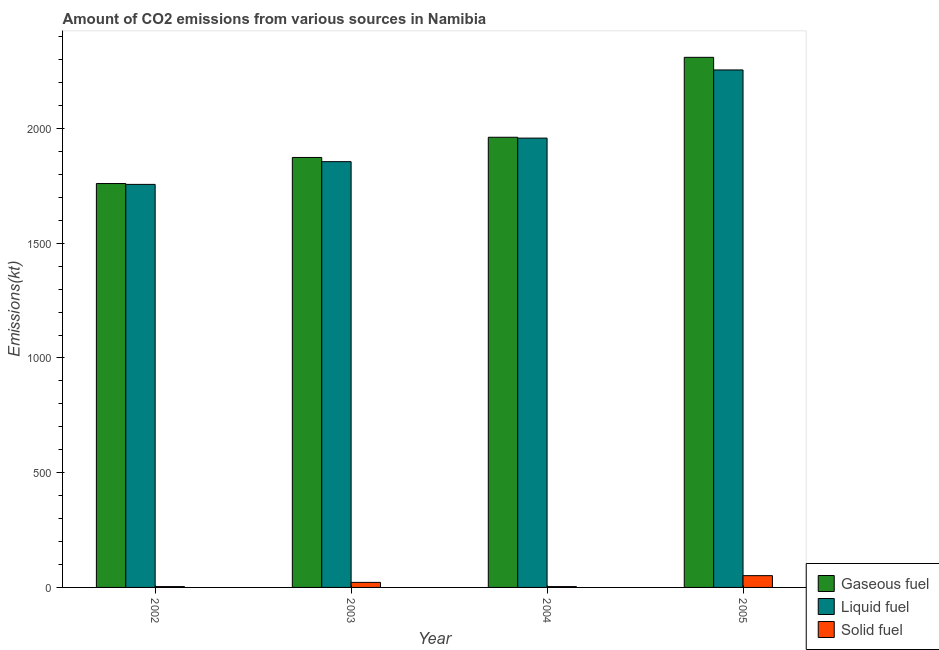How many different coloured bars are there?
Provide a short and direct response. 3. How many groups of bars are there?
Provide a succinct answer. 4. Are the number of bars per tick equal to the number of legend labels?
Your answer should be compact. Yes. How many bars are there on the 4th tick from the left?
Provide a short and direct response. 3. How many bars are there on the 1st tick from the right?
Your answer should be very brief. 3. In how many cases, is the number of bars for a given year not equal to the number of legend labels?
Your response must be concise. 0. What is the amount of co2 emissions from solid fuel in 2002?
Ensure brevity in your answer.  3.67. Across all years, what is the maximum amount of co2 emissions from gaseous fuel?
Offer a terse response. 2310.21. Across all years, what is the minimum amount of co2 emissions from gaseous fuel?
Your answer should be very brief. 1760.16. In which year was the amount of co2 emissions from liquid fuel maximum?
Your answer should be compact. 2005. In which year was the amount of co2 emissions from liquid fuel minimum?
Make the answer very short. 2002. What is the total amount of co2 emissions from liquid fuel in the graph?
Make the answer very short. 7825.38. What is the difference between the amount of co2 emissions from gaseous fuel in 2004 and that in 2005?
Your answer should be very brief. -348.37. What is the average amount of co2 emissions from liquid fuel per year?
Ensure brevity in your answer.  1956.34. In the year 2005, what is the difference between the amount of co2 emissions from gaseous fuel and amount of co2 emissions from liquid fuel?
Make the answer very short. 0. In how many years, is the amount of co2 emissions from gaseous fuel greater than 200 kt?
Your answer should be compact. 4. What is the ratio of the amount of co2 emissions from gaseous fuel in 2002 to that in 2003?
Make the answer very short. 0.94. Is the amount of co2 emissions from gaseous fuel in 2002 less than that in 2005?
Provide a succinct answer. Yes. Is the difference between the amount of co2 emissions from gaseous fuel in 2003 and 2005 greater than the difference between the amount of co2 emissions from liquid fuel in 2003 and 2005?
Keep it short and to the point. No. What is the difference between the highest and the second highest amount of co2 emissions from liquid fuel?
Your answer should be compact. 297.03. What is the difference between the highest and the lowest amount of co2 emissions from liquid fuel?
Provide a succinct answer. 498.71. In how many years, is the amount of co2 emissions from solid fuel greater than the average amount of co2 emissions from solid fuel taken over all years?
Ensure brevity in your answer.  2. What does the 3rd bar from the left in 2005 represents?
Offer a terse response. Solid fuel. What does the 1st bar from the right in 2002 represents?
Offer a terse response. Solid fuel. Is it the case that in every year, the sum of the amount of co2 emissions from gaseous fuel and amount of co2 emissions from liquid fuel is greater than the amount of co2 emissions from solid fuel?
Offer a very short reply. Yes. Are all the bars in the graph horizontal?
Make the answer very short. No. How many years are there in the graph?
Your answer should be very brief. 4. What is the difference between two consecutive major ticks on the Y-axis?
Make the answer very short. 500. Are the values on the major ticks of Y-axis written in scientific E-notation?
Keep it short and to the point. No. Does the graph contain any zero values?
Keep it short and to the point. No. Does the graph contain grids?
Your answer should be compact. No. Where does the legend appear in the graph?
Your response must be concise. Bottom right. How many legend labels are there?
Your response must be concise. 3. What is the title of the graph?
Make the answer very short. Amount of CO2 emissions from various sources in Namibia. What is the label or title of the Y-axis?
Make the answer very short. Emissions(kt). What is the Emissions(kt) of Gaseous fuel in 2002?
Offer a very short reply. 1760.16. What is the Emissions(kt) of Liquid fuel in 2002?
Your response must be concise. 1756.49. What is the Emissions(kt) in Solid fuel in 2002?
Your response must be concise. 3.67. What is the Emissions(kt) of Gaseous fuel in 2003?
Give a very brief answer. 1873.84. What is the Emissions(kt) in Liquid fuel in 2003?
Keep it short and to the point. 1855.5. What is the Emissions(kt) in Solid fuel in 2003?
Your response must be concise. 22. What is the Emissions(kt) in Gaseous fuel in 2004?
Ensure brevity in your answer.  1961.85. What is the Emissions(kt) in Liquid fuel in 2004?
Make the answer very short. 1958.18. What is the Emissions(kt) in Solid fuel in 2004?
Your answer should be very brief. 3.67. What is the Emissions(kt) in Gaseous fuel in 2005?
Your answer should be compact. 2310.21. What is the Emissions(kt) of Liquid fuel in 2005?
Keep it short and to the point. 2255.2. What is the Emissions(kt) of Solid fuel in 2005?
Ensure brevity in your answer.  51.34. Across all years, what is the maximum Emissions(kt) in Gaseous fuel?
Ensure brevity in your answer.  2310.21. Across all years, what is the maximum Emissions(kt) of Liquid fuel?
Give a very brief answer. 2255.2. Across all years, what is the maximum Emissions(kt) of Solid fuel?
Provide a succinct answer. 51.34. Across all years, what is the minimum Emissions(kt) in Gaseous fuel?
Provide a short and direct response. 1760.16. Across all years, what is the minimum Emissions(kt) in Liquid fuel?
Offer a terse response. 1756.49. Across all years, what is the minimum Emissions(kt) in Solid fuel?
Ensure brevity in your answer.  3.67. What is the total Emissions(kt) in Gaseous fuel in the graph?
Your answer should be very brief. 7906.05. What is the total Emissions(kt) of Liquid fuel in the graph?
Offer a terse response. 7825.38. What is the total Emissions(kt) in Solid fuel in the graph?
Keep it short and to the point. 80.67. What is the difference between the Emissions(kt) in Gaseous fuel in 2002 and that in 2003?
Provide a succinct answer. -113.68. What is the difference between the Emissions(kt) in Liquid fuel in 2002 and that in 2003?
Your response must be concise. -99.01. What is the difference between the Emissions(kt) in Solid fuel in 2002 and that in 2003?
Provide a short and direct response. -18.34. What is the difference between the Emissions(kt) of Gaseous fuel in 2002 and that in 2004?
Make the answer very short. -201.69. What is the difference between the Emissions(kt) in Liquid fuel in 2002 and that in 2004?
Give a very brief answer. -201.69. What is the difference between the Emissions(kt) of Solid fuel in 2002 and that in 2004?
Make the answer very short. 0. What is the difference between the Emissions(kt) in Gaseous fuel in 2002 and that in 2005?
Your response must be concise. -550.05. What is the difference between the Emissions(kt) in Liquid fuel in 2002 and that in 2005?
Give a very brief answer. -498.71. What is the difference between the Emissions(kt) of Solid fuel in 2002 and that in 2005?
Make the answer very short. -47.67. What is the difference between the Emissions(kt) of Gaseous fuel in 2003 and that in 2004?
Offer a terse response. -88.01. What is the difference between the Emissions(kt) in Liquid fuel in 2003 and that in 2004?
Make the answer very short. -102.68. What is the difference between the Emissions(kt) of Solid fuel in 2003 and that in 2004?
Provide a short and direct response. 18.34. What is the difference between the Emissions(kt) in Gaseous fuel in 2003 and that in 2005?
Give a very brief answer. -436.37. What is the difference between the Emissions(kt) in Liquid fuel in 2003 and that in 2005?
Offer a terse response. -399.7. What is the difference between the Emissions(kt) in Solid fuel in 2003 and that in 2005?
Make the answer very short. -29.34. What is the difference between the Emissions(kt) in Gaseous fuel in 2004 and that in 2005?
Your answer should be very brief. -348.37. What is the difference between the Emissions(kt) of Liquid fuel in 2004 and that in 2005?
Your response must be concise. -297.03. What is the difference between the Emissions(kt) in Solid fuel in 2004 and that in 2005?
Give a very brief answer. -47.67. What is the difference between the Emissions(kt) of Gaseous fuel in 2002 and the Emissions(kt) of Liquid fuel in 2003?
Keep it short and to the point. -95.34. What is the difference between the Emissions(kt) in Gaseous fuel in 2002 and the Emissions(kt) in Solid fuel in 2003?
Your answer should be compact. 1738.16. What is the difference between the Emissions(kt) in Liquid fuel in 2002 and the Emissions(kt) in Solid fuel in 2003?
Ensure brevity in your answer.  1734.49. What is the difference between the Emissions(kt) in Gaseous fuel in 2002 and the Emissions(kt) in Liquid fuel in 2004?
Keep it short and to the point. -198.02. What is the difference between the Emissions(kt) in Gaseous fuel in 2002 and the Emissions(kt) in Solid fuel in 2004?
Provide a succinct answer. 1756.49. What is the difference between the Emissions(kt) in Liquid fuel in 2002 and the Emissions(kt) in Solid fuel in 2004?
Your answer should be compact. 1752.83. What is the difference between the Emissions(kt) of Gaseous fuel in 2002 and the Emissions(kt) of Liquid fuel in 2005?
Make the answer very short. -495.05. What is the difference between the Emissions(kt) in Gaseous fuel in 2002 and the Emissions(kt) in Solid fuel in 2005?
Make the answer very short. 1708.82. What is the difference between the Emissions(kt) in Liquid fuel in 2002 and the Emissions(kt) in Solid fuel in 2005?
Your answer should be compact. 1705.15. What is the difference between the Emissions(kt) in Gaseous fuel in 2003 and the Emissions(kt) in Liquid fuel in 2004?
Give a very brief answer. -84.34. What is the difference between the Emissions(kt) in Gaseous fuel in 2003 and the Emissions(kt) in Solid fuel in 2004?
Offer a very short reply. 1870.17. What is the difference between the Emissions(kt) of Liquid fuel in 2003 and the Emissions(kt) of Solid fuel in 2004?
Give a very brief answer. 1851.84. What is the difference between the Emissions(kt) in Gaseous fuel in 2003 and the Emissions(kt) in Liquid fuel in 2005?
Ensure brevity in your answer.  -381.37. What is the difference between the Emissions(kt) of Gaseous fuel in 2003 and the Emissions(kt) of Solid fuel in 2005?
Offer a terse response. 1822.5. What is the difference between the Emissions(kt) of Liquid fuel in 2003 and the Emissions(kt) of Solid fuel in 2005?
Your answer should be very brief. 1804.16. What is the difference between the Emissions(kt) in Gaseous fuel in 2004 and the Emissions(kt) in Liquid fuel in 2005?
Your answer should be very brief. -293.36. What is the difference between the Emissions(kt) of Gaseous fuel in 2004 and the Emissions(kt) of Solid fuel in 2005?
Your answer should be very brief. 1910.51. What is the difference between the Emissions(kt) in Liquid fuel in 2004 and the Emissions(kt) in Solid fuel in 2005?
Keep it short and to the point. 1906.84. What is the average Emissions(kt) in Gaseous fuel per year?
Offer a very short reply. 1976.51. What is the average Emissions(kt) in Liquid fuel per year?
Your answer should be compact. 1956.34. What is the average Emissions(kt) in Solid fuel per year?
Your answer should be very brief. 20.17. In the year 2002, what is the difference between the Emissions(kt) of Gaseous fuel and Emissions(kt) of Liquid fuel?
Make the answer very short. 3.67. In the year 2002, what is the difference between the Emissions(kt) of Gaseous fuel and Emissions(kt) of Solid fuel?
Offer a very short reply. 1756.49. In the year 2002, what is the difference between the Emissions(kt) of Liquid fuel and Emissions(kt) of Solid fuel?
Keep it short and to the point. 1752.83. In the year 2003, what is the difference between the Emissions(kt) in Gaseous fuel and Emissions(kt) in Liquid fuel?
Offer a very short reply. 18.34. In the year 2003, what is the difference between the Emissions(kt) of Gaseous fuel and Emissions(kt) of Solid fuel?
Keep it short and to the point. 1851.84. In the year 2003, what is the difference between the Emissions(kt) of Liquid fuel and Emissions(kt) of Solid fuel?
Keep it short and to the point. 1833.5. In the year 2004, what is the difference between the Emissions(kt) of Gaseous fuel and Emissions(kt) of Liquid fuel?
Offer a terse response. 3.67. In the year 2004, what is the difference between the Emissions(kt) in Gaseous fuel and Emissions(kt) in Solid fuel?
Keep it short and to the point. 1958.18. In the year 2004, what is the difference between the Emissions(kt) of Liquid fuel and Emissions(kt) of Solid fuel?
Give a very brief answer. 1954.51. In the year 2005, what is the difference between the Emissions(kt) in Gaseous fuel and Emissions(kt) in Liquid fuel?
Keep it short and to the point. 55.01. In the year 2005, what is the difference between the Emissions(kt) in Gaseous fuel and Emissions(kt) in Solid fuel?
Make the answer very short. 2258.87. In the year 2005, what is the difference between the Emissions(kt) of Liquid fuel and Emissions(kt) of Solid fuel?
Offer a terse response. 2203.87. What is the ratio of the Emissions(kt) of Gaseous fuel in 2002 to that in 2003?
Give a very brief answer. 0.94. What is the ratio of the Emissions(kt) in Liquid fuel in 2002 to that in 2003?
Your answer should be compact. 0.95. What is the ratio of the Emissions(kt) of Gaseous fuel in 2002 to that in 2004?
Keep it short and to the point. 0.9. What is the ratio of the Emissions(kt) of Liquid fuel in 2002 to that in 2004?
Make the answer very short. 0.9. What is the ratio of the Emissions(kt) of Gaseous fuel in 2002 to that in 2005?
Ensure brevity in your answer.  0.76. What is the ratio of the Emissions(kt) of Liquid fuel in 2002 to that in 2005?
Provide a succinct answer. 0.78. What is the ratio of the Emissions(kt) in Solid fuel in 2002 to that in 2005?
Offer a terse response. 0.07. What is the ratio of the Emissions(kt) in Gaseous fuel in 2003 to that in 2004?
Provide a succinct answer. 0.96. What is the ratio of the Emissions(kt) of Liquid fuel in 2003 to that in 2004?
Give a very brief answer. 0.95. What is the ratio of the Emissions(kt) in Gaseous fuel in 2003 to that in 2005?
Offer a very short reply. 0.81. What is the ratio of the Emissions(kt) in Liquid fuel in 2003 to that in 2005?
Your answer should be very brief. 0.82. What is the ratio of the Emissions(kt) of Solid fuel in 2003 to that in 2005?
Provide a short and direct response. 0.43. What is the ratio of the Emissions(kt) in Gaseous fuel in 2004 to that in 2005?
Your response must be concise. 0.85. What is the ratio of the Emissions(kt) in Liquid fuel in 2004 to that in 2005?
Keep it short and to the point. 0.87. What is the ratio of the Emissions(kt) in Solid fuel in 2004 to that in 2005?
Offer a terse response. 0.07. What is the difference between the highest and the second highest Emissions(kt) in Gaseous fuel?
Offer a very short reply. 348.37. What is the difference between the highest and the second highest Emissions(kt) of Liquid fuel?
Give a very brief answer. 297.03. What is the difference between the highest and the second highest Emissions(kt) of Solid fuel?
Provide a succinct answer. 29.34. What is the difference between the highest and the lowest Emissions(kt) of Gaseous fuel?
Give a very brief answer. 550.05. What is the difference between the highest and the lowest Emissions(kt) of Liquid fuel?
Your answer should be compact. 498.71. What is the difference between the highest and the lowest Emissions(kt) of Solid fuel?
Provide a short and direct response. 47.67. 